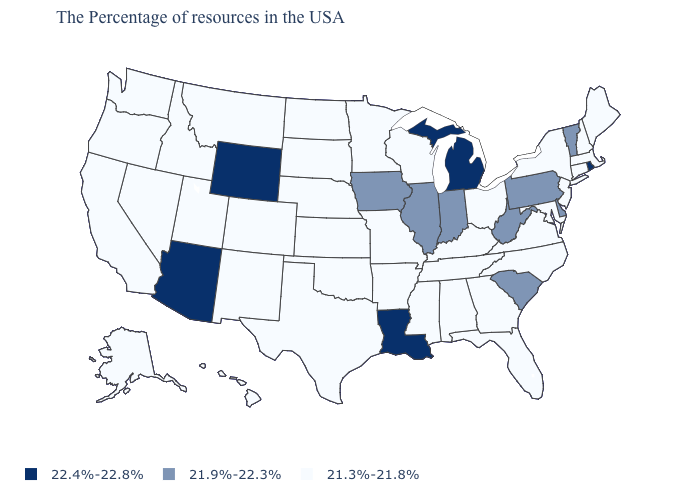What is the value of Missouri?
Write a very short answer. 21.3%-21.8%. What is the value of West Virginia?
Write a very short answer. 21.9%-22.3%. What is the value of Hawaii?
Short answer required. 21.3%-21.8%. Does South Dakota have a higher value than Nevada?
Give a very brief answer. No. Is the legend a continuous bar?
Give a very brief answer. No. Which states hav the highest value in the Northeast?
Give a very brief answer. Rhode Island. Does Montana have the lowest value in the West?
Concise answer only. Yes. Name the states that have a value in the range 21.9%-22.3%?
Short answer required. Vermont, Delaware, Pennsylvania, South Carolina, West Virginia, Indiana, Illinois, Iowa. Name the states that have a value in the range 22.4%-22.8%?
Keep it brief. Rhode Island, Michigan, Louisiana, Wyoming, Arizona. Does the map have missing data?
Quick response, please. No. Name the states that have a value in the range 21.9%-22.3%?
Keep it brief. Vermont, Delaware, Pennsylvania, South Carolina, West Virginia, Indiana, Illinois, Iowa. Does Washington have the lowest value in the USA?
Be succinct. Yes. Name the states that have a value in the range 21.3%-21.8%?
Short answer required. Maine, Massachusetts, New Hampshire, Connecticut, New York, New Jersey, Maryland, Virginia, North Carolina, Ohio, Florida, Georgia, Kentucky, Alabama, Tennessee, Wisconsin, Mississippi, Missouri, Arkansas, Minnesota, Kansas, Nebraska, Oklahoma, Texas, South Dakota, North Dakota, Colorado, New Mexico, Utah, Montana, Idaho, Nevada, California, Washington, Oregon, Alaska, Hawaii. What is the value of Michigan?
Write a very short answer. 22.4%-22.8%. 